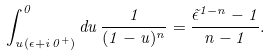<formula> <loc_0><loc_0><loc_500><loc_500>\int _ { u ( \epsilon + i \, 0 ^ { + } ) } ^ { 0 } d u \, \frac { 1 } { ( 1 - u ) ^ { n } } = \frac { { \tilde { \epsilon } } ^ { 1 - n } - 1 } { n - 1 } .</formula> 